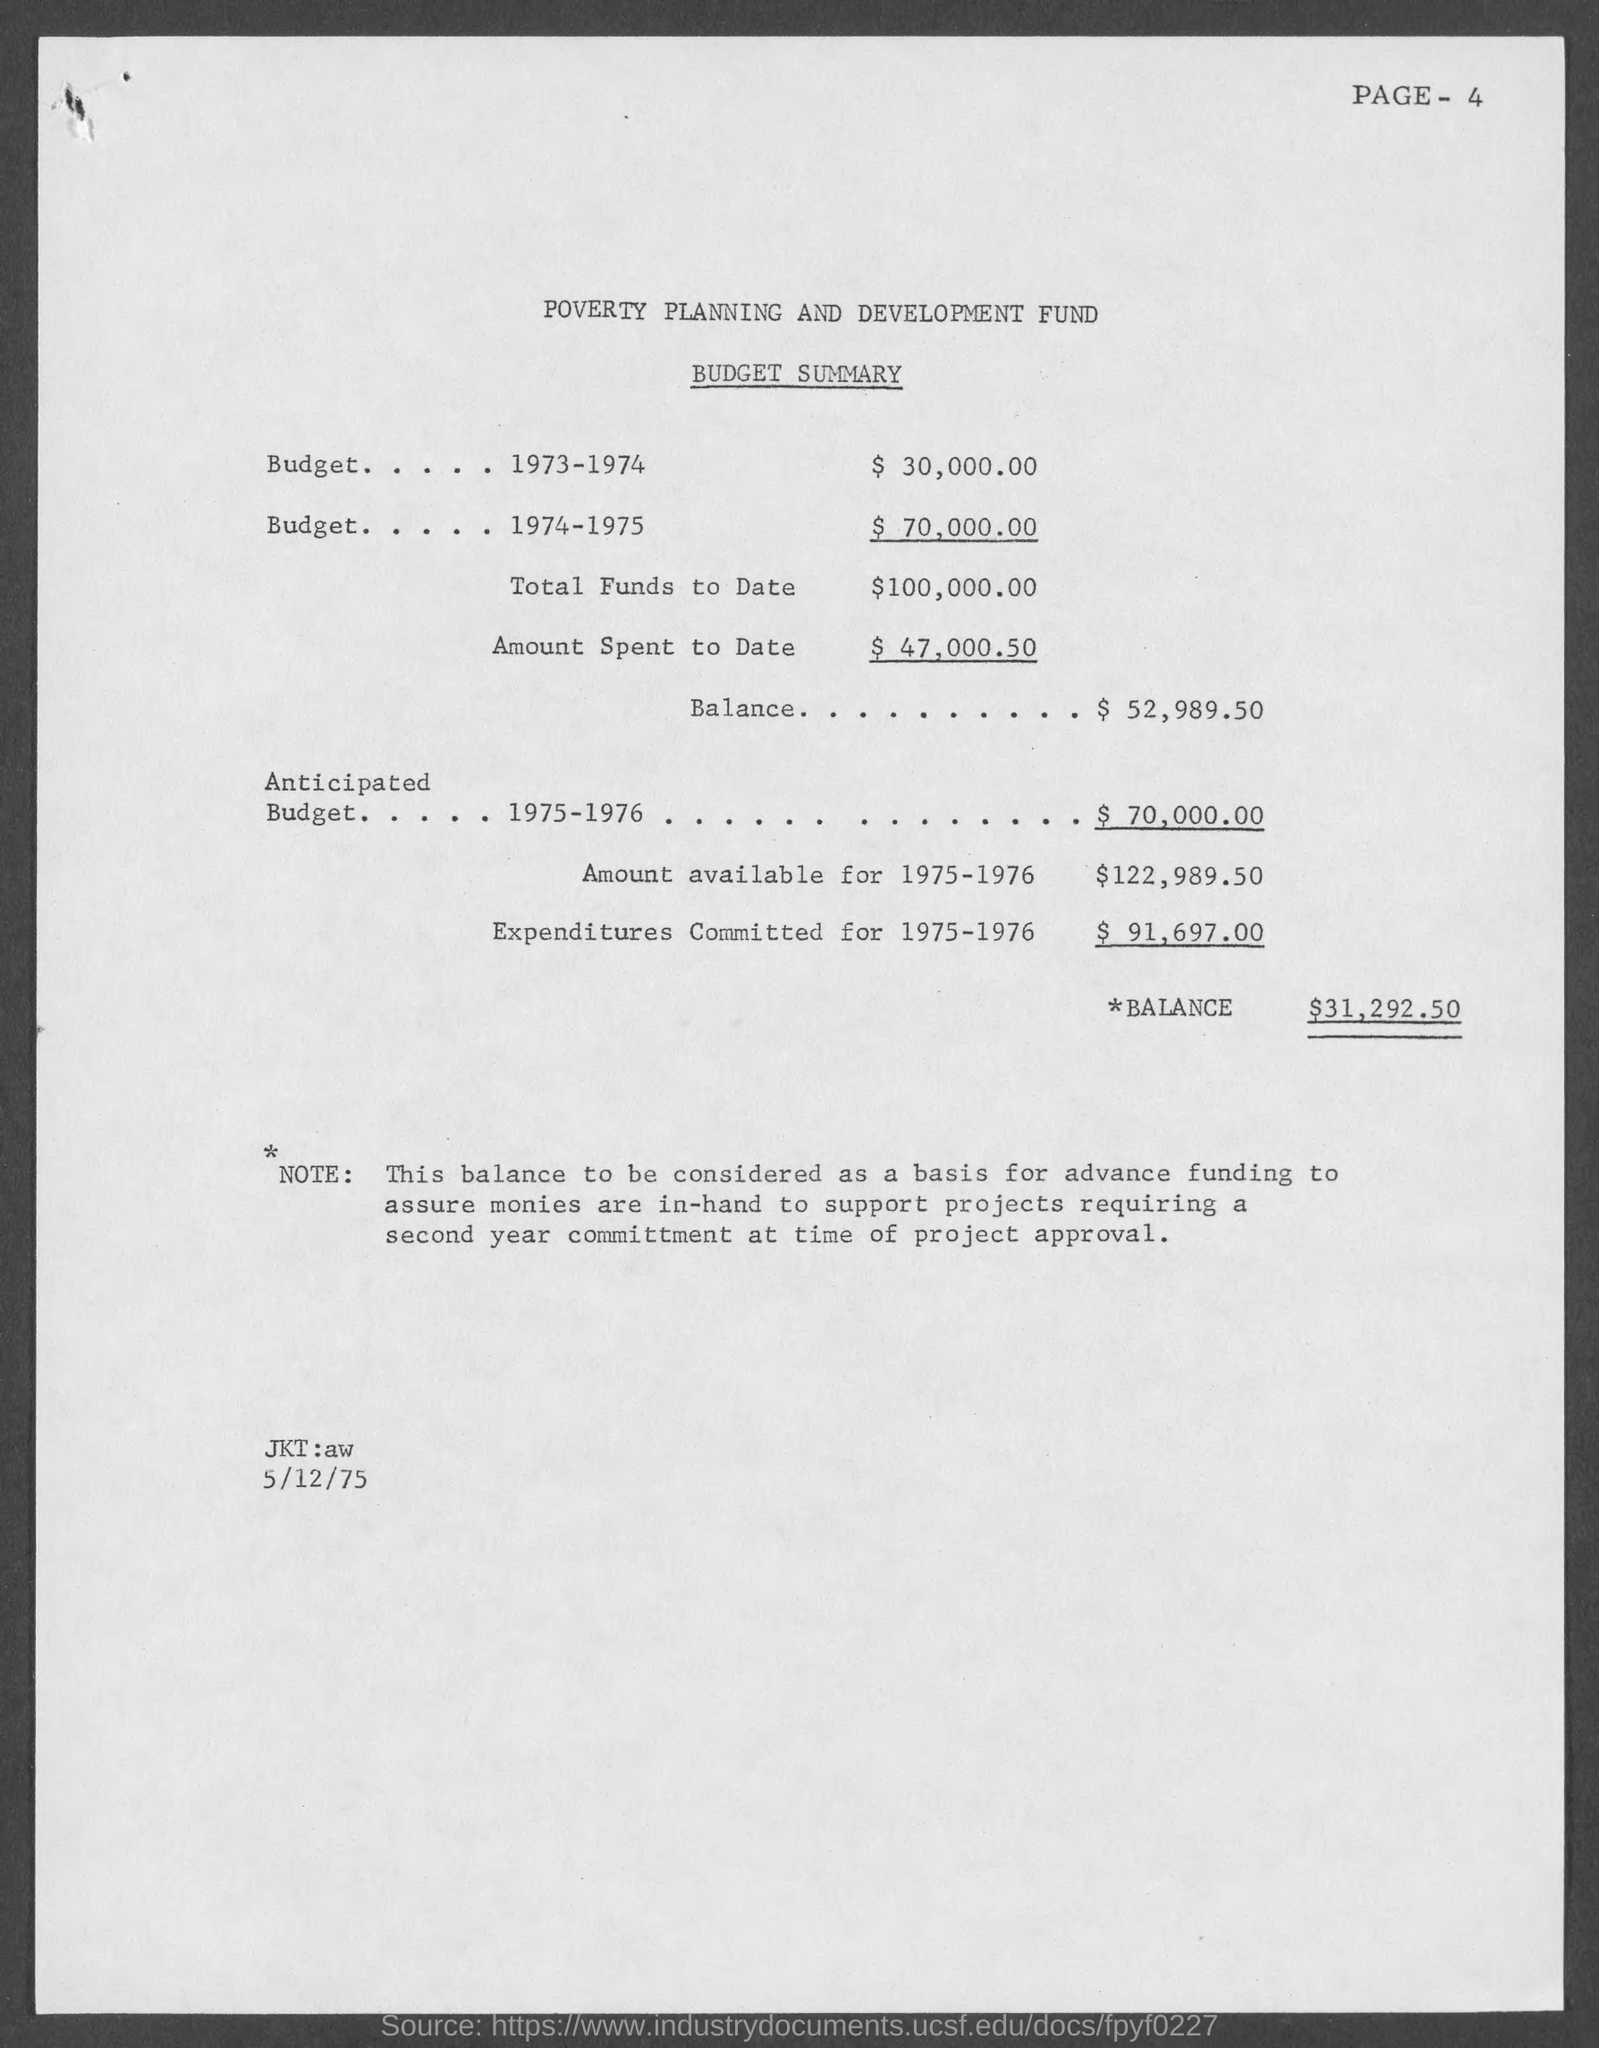What is the page no mentioned in this document?
Make the answer very short. PAGE- 4. What is the budget estimate for the year 1973-1974?
Provide a succinct answer. $   30,000.00. What is the budget estimate for the year 1974-1975?
Provide a short and direct response. 70,000.00. What is the total funds to date given in the budget summary?
Ensure brevity in your answer.  100,000.00. What is the amount spent to date as per the budget summary?
Keep it short and to the point. 47,000.50. What is the Anticipated budget for the year 1975-1976?
Offer a terse response. $ 70,000.00. What is the expenditures committed for 1975-1976 as per the budget summary?
Offer a terse response. $  91,697.00. What is the amount available for 1975-1976 mentioned in the budget summary?
Give a very brief answer. $122,989.50. What is the date mentioned in the budget summary?
Your answer should be compact. 5/12/75. 